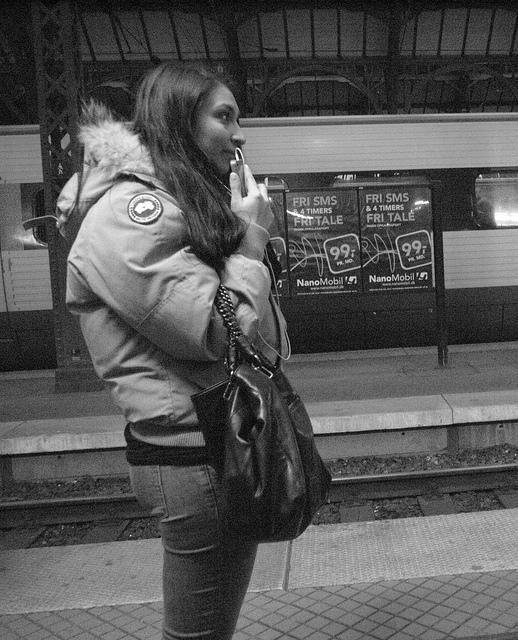How many bears are there?
Give a very brief answer. 0. 